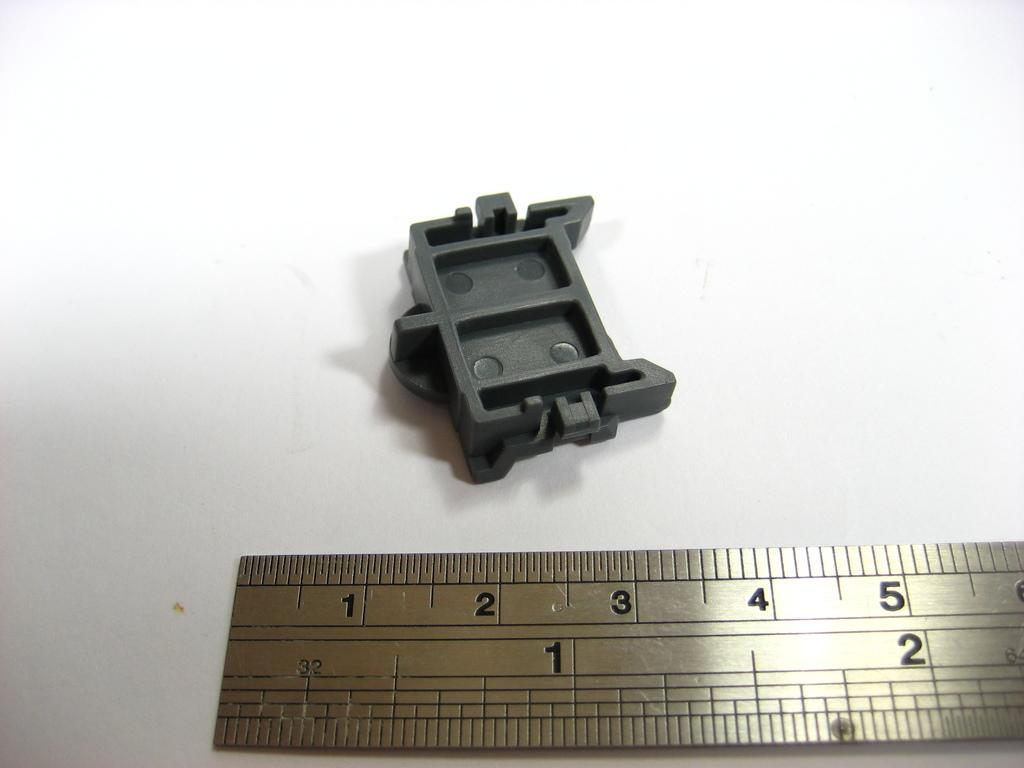<image>
Provide a brief description of the given image. Above a stainless steel ruler, showing just over the first two inches, is a small, grey plastic component on a white surface. 